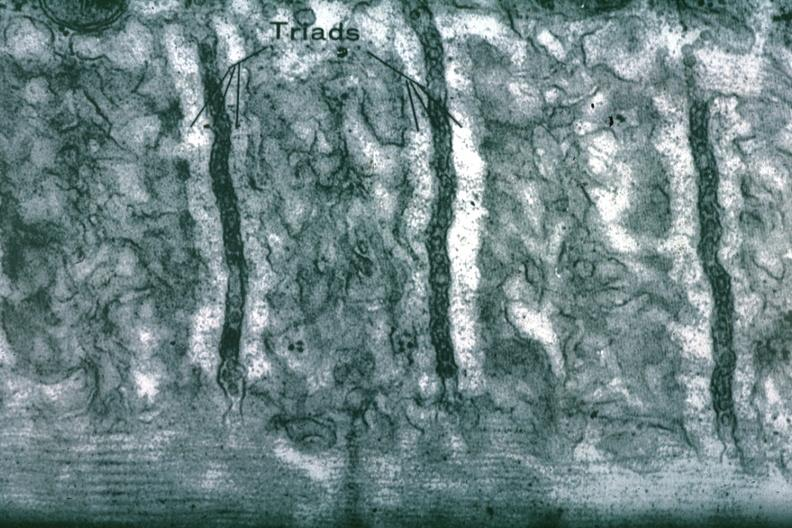s breast present?
Answer the question using a single word or phrase. No 